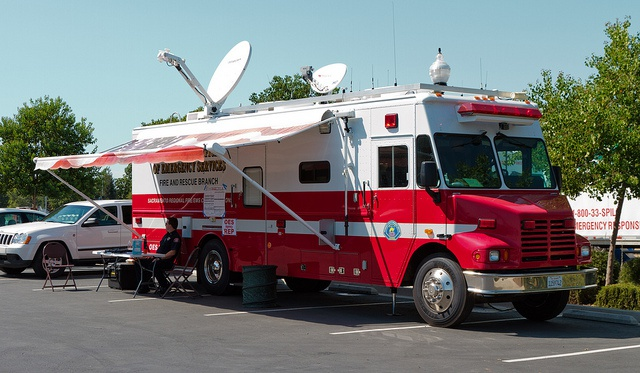Describe the objects in this image and their specific colors. I can see truck in lightblue, black, maroon, white, and gray tones, car in lightblue, black, gray, and white tones, truck in lightblue, black, gray, and white tones, people in lightblue, black, maroon, gray, and red tones, and chair in lightblue, black, and gray tones in this image. 